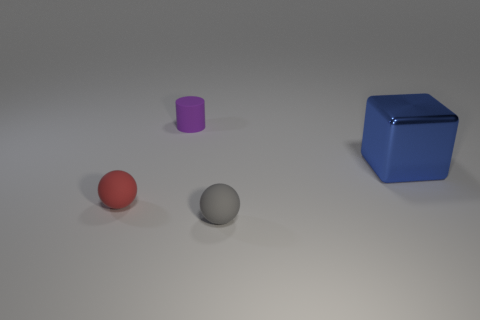Add 3 large metallic objects. How many objects exist? 7 Add 1 shiny cubes. How many shiny cubes exist? 2 Subtract 0 green cylinders. How many objects are left? 4 Subtract all cyan balls. Subtract all green cubes. How many balls are left? 2 Subtract all gray blocks. How many cyan cylinders are left? 0 Subtract all blue metal things. Subtract all large brown cubes. How many objects are left? 3 Add 1 purple matte cylinders. How many purple matte cylinders are left? 2 